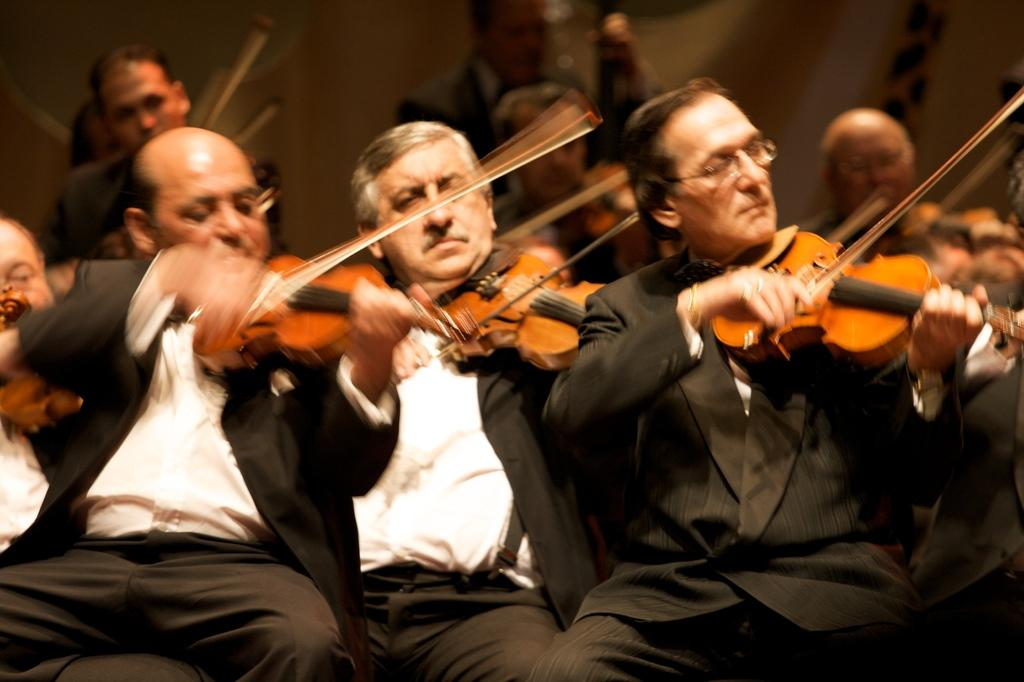Who are the people in the image? The facts provided do not give specific names of the people in the image. What are the people doing in the image? The people in the image are sitting and playing an instrument. How many people are playing instruments in the image? The facts provided do not specify the exact number of people playing instruments, but it can be inferred that there are at least two people since the plural form "people" is used. What is the history of the distribution of the instruments in the image? There is no information about the history or distribution of the instruments in the image. 